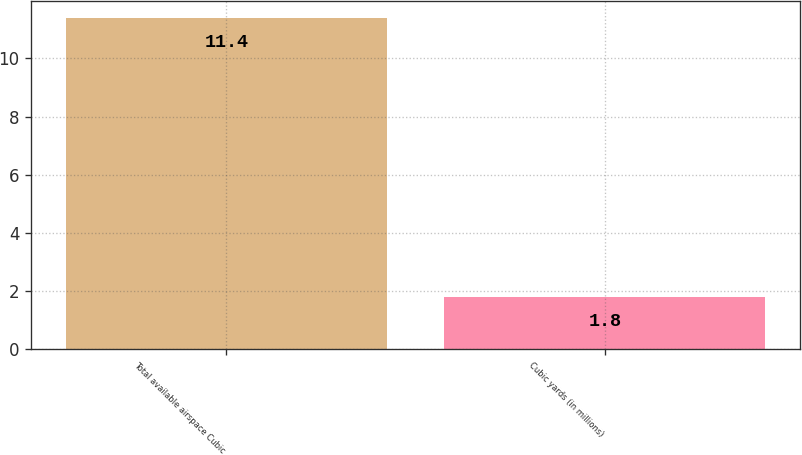Convert chart to OTSL. <chart><loc_0><loc_0><loc_500><loc_500><bar_chart><fcel>Total available airspace Cubic<fcel>Cubic yards (in millions)<nl><fcel>11.4<fcel>1.8<nl></chart> 